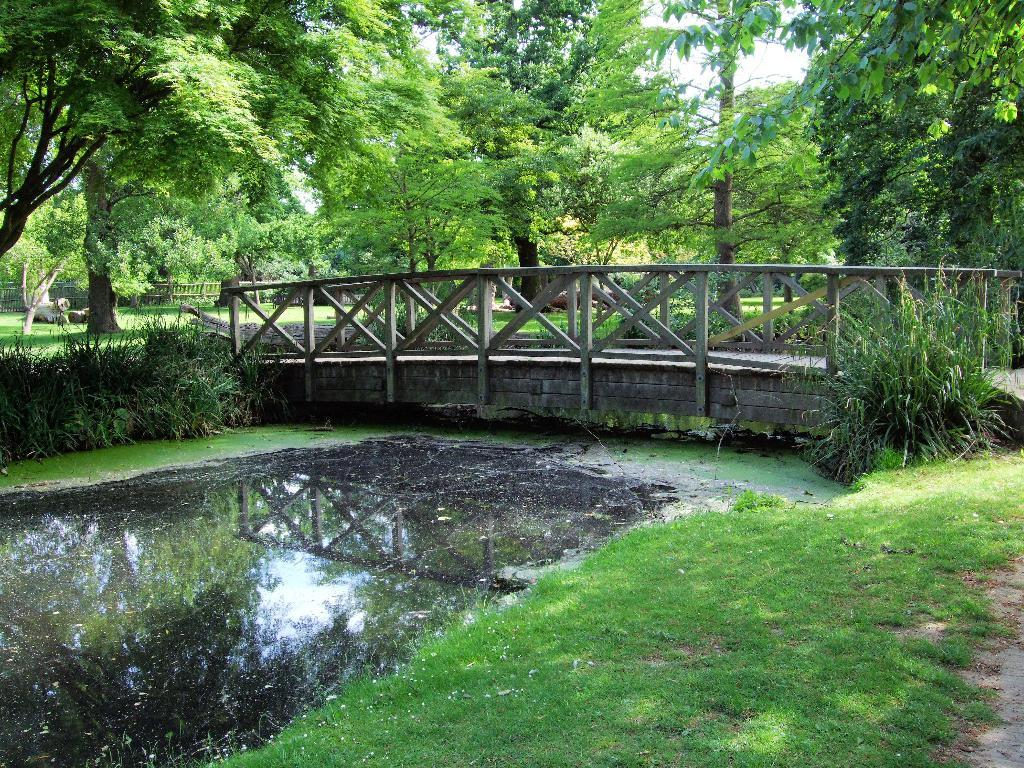What type of vegetation is present in the image? There are green trees in the image. What natural element can be seen alongside the trees? There is water visible in the image. What structure is present in the image that connects two areas? There is a bridge in the image. What is the color of the sky in the image? The sky appears to be white in color. Can you see any quivers in the image? There is no, There is no mention of quivers in the provided facts, and therefore, we cannot confirm their presence in the image. 